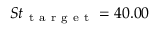<formula> <loc_0><loc_0><loc_500><loc_500>S t _ { t a r g e t } = 4 0 . 0 0</formula> 